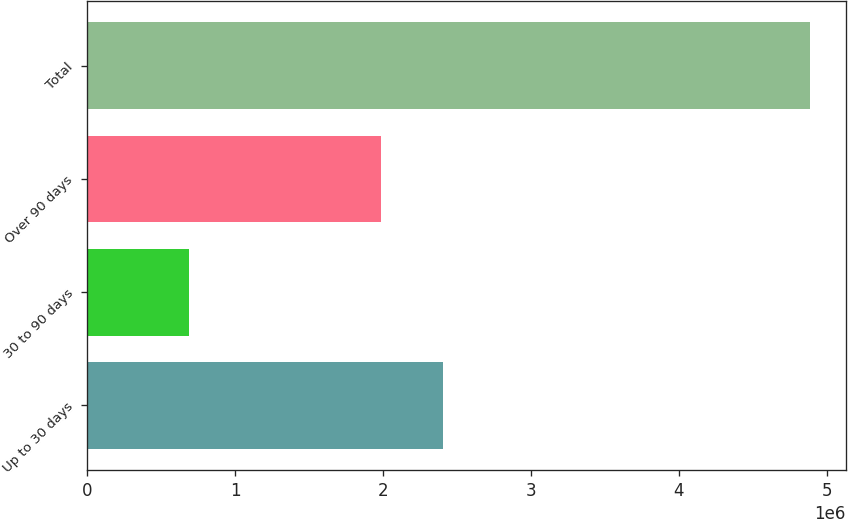Convert chart to OTSL. <chart><loc_0><loc_0><loc_500><loc_500><bar_chart><fcel>Up to 30 days<fcel>30 to 90 days<fcel>Over 90 days<fcel>Total<nl><fcel>2.40256e+06<fcel>689765<fcel>1.98308e+06<fcel>4.88457e+06<nl></chart> 